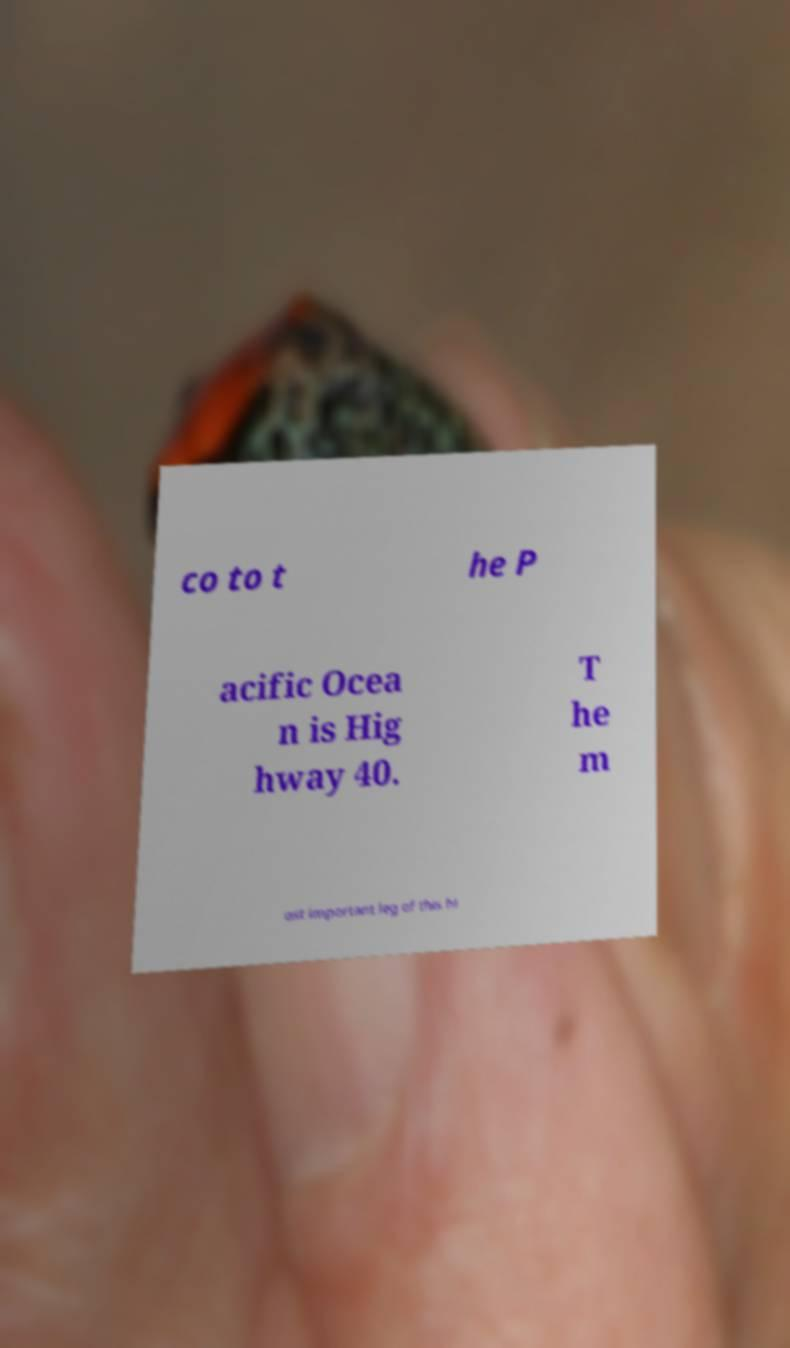Can you accurately transcribe the text from the provided image for me? co to t he P acific Ocea n is Hig hway 40. T he m ost important leg of this hi 